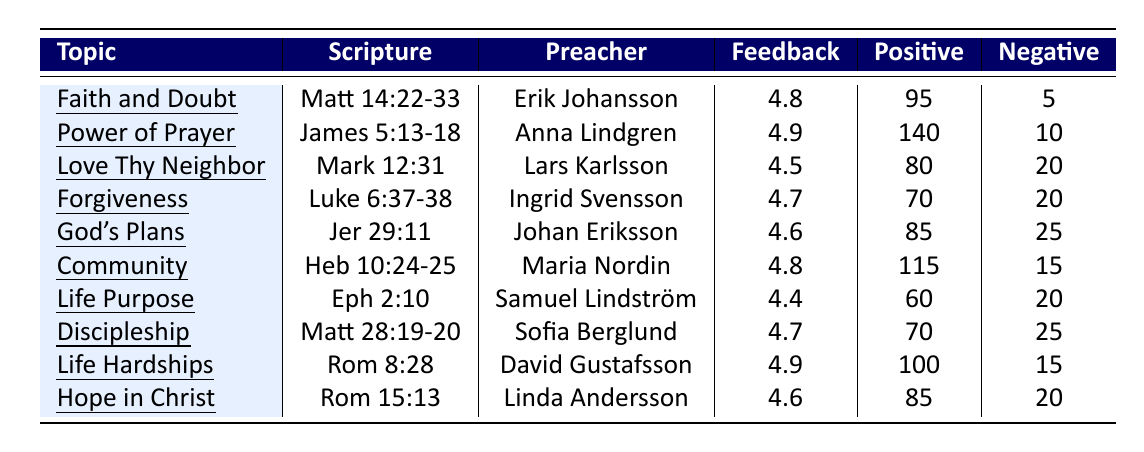What is the feedback strength for the sermon titled "The Power of Prayer"? From the table, we can find the feedback strength listed under the topic "The Power of Prayer". It shows a value of 4.9.
Answer: 4.9 How many positive comments were received for the sermon "Love Thy Neighbor"? The table indicates that "Love Thy Neighbor" received a total of 80 positive comments.
Answer: 80 What was the feedback volume for the sermon "Community and Fellowship"? Looking at the table, the feedback volume for the sermon "Community and Fellowship" is listed as 130.
Answer: 130 Which sermon topic had the highest number of negative comments? To determine this, we compare the "Negative" column values for each sermon. "God's Plans for Us" had the highest with 25 negative comments.
Answer: God's Plans for Us What is the average feedback strength of all sermons listed? We sum the feedback strengths: (4.8 + 4.9 + 4.5 + 4.7 + 4.6 + 4.8 + 4.4 + 4.7 + 4.9 + 4.6) = 48.9. There are 10 sermons, so the average is 48.9 / 10 = 4.89.
Answer: 4.89 Which preacher had the most positive comments for their sermon? By checking the positive comments, Pastor Anna Lindgren's sermon "The Power of Prayer" received the most with 140 positive comments.
Answer: Pastor Anna Lindgren Is there a sermon on "Forgiveness" with a feedback strength of at least 4.5? Yes, the sermon "Forgiveness and Healing" has a feedback strength of 4.7, which meets the criteria.
Answer: Yes What is the difference in positive comments between the sermons "Living a Life of Purpose" and "Forgiveness and Healing"? "Living a Life of Purpose" has 60 positive comments, and "Forgiveness and Healing" has 70. The difference is 70 - 60 = 10.
Answer: 10 Identify the sermon with the lowest feedback strength. Analyzing the feedback strengths, "Living a Life of Purpose" has the lowest at 4.4 among all listed sermons.
Answer: Living a Life of Purpose What was the sum of negative comments across all sermons? We sum the negative comments: (5 + 10 + 20 + 20 + 25 + 15 + 20 + 25 + 15 + 20) = 185.
Answer: 185 Which sermon had feedback strength greater than 4.5 but less than 4.8? The sermons "God's Plans for Us" (4.6) and "Hope in Christ" (4.6) had feedback strengths in that range.
Answer: God's Plans for Us, Hope in Christ 